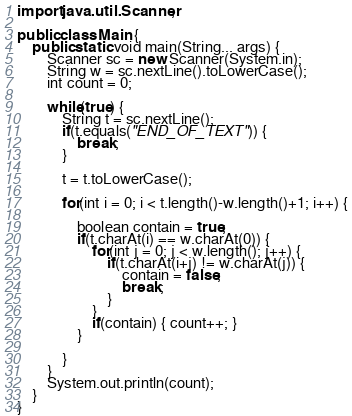<code> <loc_0><loc_0><loc_500><loc_500><_Java_>import java.util.Scanner;

public class Main {
    public static void main(String... args) {
        Scanner sc = new Scanner(System.in);
        String w = sc.nextLine().toLowerCase();
        int count = 0;

        while(true) {
        	String t = sc.nextLine();
        	if(t.equals("END_OF_TEXT")) {
        		break;
        	}
        	
        	t = t.toLowerCase();

        	for(int i = 0; i < t.length()-w.length()+1; i++) {

        		boolean contain = true;
        		if(t.charAt(i) == w.charAt(0)) {
        			for(int j = 0; j < w.length(); j++) {
        				if(t.charAt(i+j) != w.charAt(j)) {
        					contain = false;
        					break;
        				}
        			}
        			if(contain) { count++; }
        		}

        	}
        }
        System.out.println(count);
    }
}
</code> 